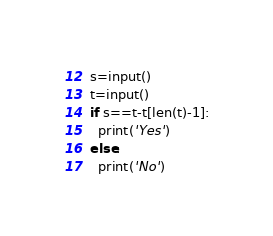Convert code to text. <code><loc_0><loc_0><loc_500><loc_500><_Python_>s=input()
t=input()
if s==t-t[len(t)-1]:
  print('Yes')
else:
  print('No')
</code> 